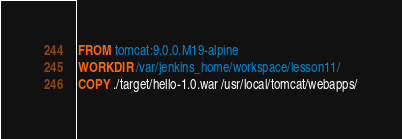<code> <loc_0><loc_0><loc_500><loc_500><_Dockerfile_>FROM tomcat:9.0.0.M19-alpine
WORKDIR /var/jenkins_home/workspace/lesson11/
COPY ./target/hello-1.0.war /usr/local/tomcat/webapps/</code> 